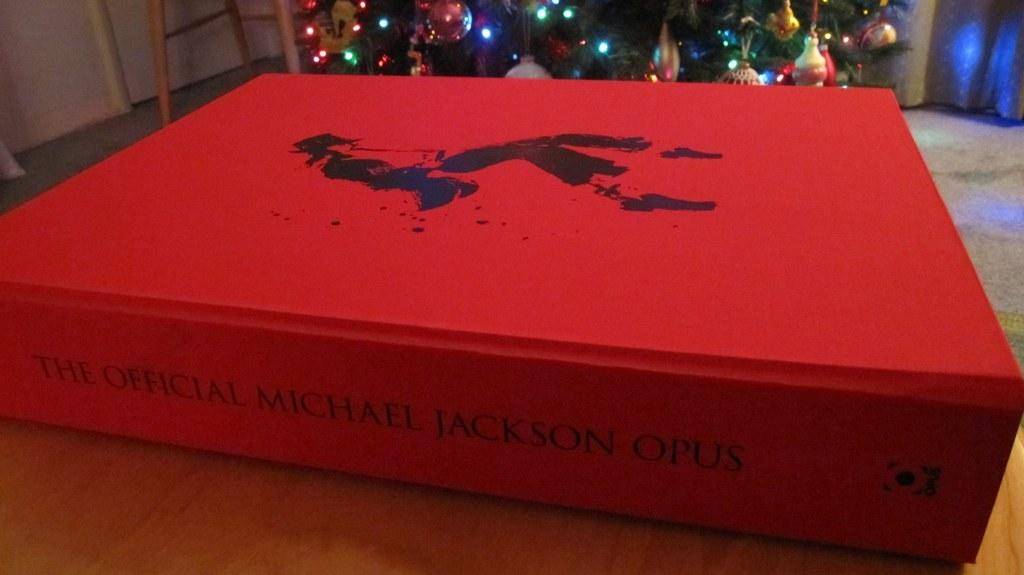<image>
Render a clear and concise summary of the photo. A red book with the title The official Michael Jackson Opus on the spine. 